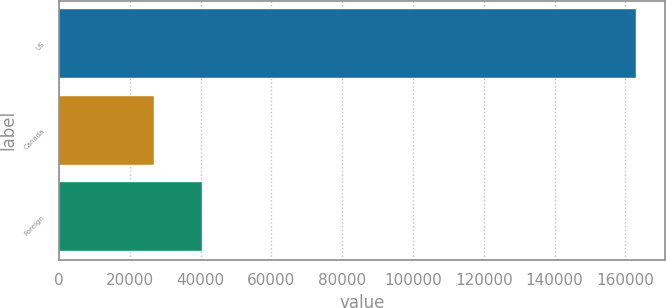<chart> <loc_0><loc_0><loc_500><loc_500><bar_chart><fcel>US<fcel>Canada<fcel>Foreign<nl><fcel>163028<fcel>26816<fcel>40437.2<nl></chart> 